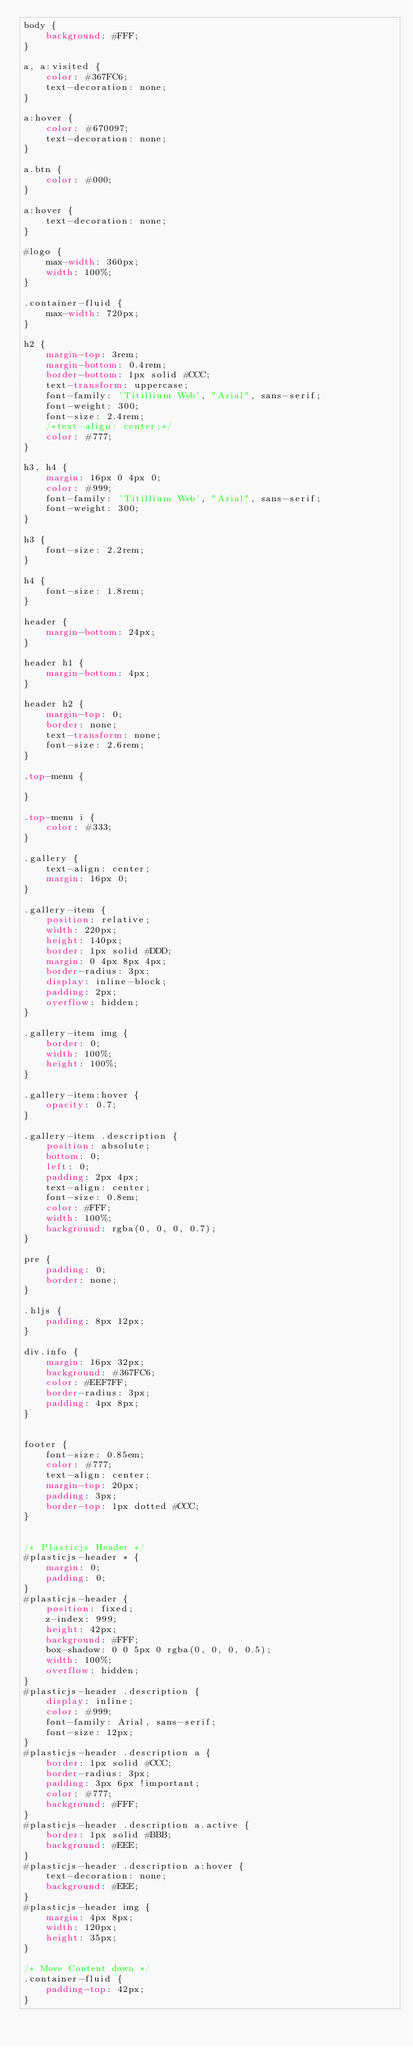<code> <loc_0><loc_0><loc_500><loc_500><_CSS_>body {
    background: #FFF;
}

a, a:visited {
    color: #367FC6;
    text-decoration: none;
}

a:hover {
    color: #670097;
    text-decoration: none;
}

a.btn {
    color: #000;
}

a:hover {
    text-decoration: none;
}

#logo {
    max-width: 360px;
    width: 100%;
}

.container-fluid {
    max-width: 720px;
}

h2 {
    margin-top: 3rem;
    margin-bottom: 0.4rem;
    border-bottom: 1px solid #CCC;
    text-transform: uppercase;
    font-family: 'Titillium Web', "Arial", sans-serif;
    font-weight: 300;
    font-size: 2.4rem;
    /*text-align: center;*/
    color: #777;
}

h3, h4 {
    margin: 16px 0 4px 0;
    color: #999;
    font-family: 'Titillium Web', "Arial", sans-serif;
    font-weight: 300;
}

h3 {
    font-size: 2.2rem;
}

h4 {
    font-size: 1.8rem;
}

header {
    margin-bottom: 24px;
}

header h1 {
    margin-bottom: 4px;
}

header h2 {
    margin-top: 0;
    border: none;
    text-transform: none;
    font-size: 2.6rem;
}

.top-menu {

}

.top-menu i {
    color: #333;
}

.gallery {
    text-align: center;
    margin: 16px 0;
}

.gallery-item {
    position: relative;
    width: 220px;
    height: 140px;
    border: 1px solid #DDD;
    margin: 0 4px 8px 4px;
    border-radius: 3px;
    display: inline-block;
    padding: 2px;
    overflow: hidden;
}

.gallery-item img {
    border: 0;
    width: 100%;
    height: 100%;
}

.gallery-item:hover {
    opacity: 0.7;
}

.gallery-item .description {
    position: absolute;
    bottom: 0;
    left: 0;
    padding: 2px 4px;
    text-align: center;
    font-size: 0.8em;
    color: #FFF;
    width: 100%;
    background: rgba(0, 0, 0, 0.7);
}

pre {
    padding: 0;
    border: none;
}

.hljs {
    padding: 8px 12px;
}

div.info {
    margin: 16px 32px;
    background: #367FC6;
    color: #EEF7FF;
    border-radius: 3px;
    padding: 4px 8px;
}


footer {
    font-size: 0.85em;
    color: #777;
    text-align: center;
    margin-top: 20px;
    padding: 3px;
    border-top: 1px dotted #CCC;
}


/* Plasticjs Header */
#plasticjs-header * {
    margin: 0;
    padding: 0;
}
#plasticjs-header {
    position: fixed;
    z-index: 999;
    height: 42px;
    background: #FFF;
    box-shadow: 0 0 5px 0 rgba(0, 0, 0, 0.5);
    width: 100%;
    overflow: hidden;
}
#plasticjs-header .description {
    display: inline;
    color: #999;
    font-family: Arial, sans-serif;
    font-size: 12px;
}
#plasticjs-header .description a {
    border: 1px solid #CCC;
    border-radius: 3px;
    padding: 3px 6px !important;
    color: #777;
    background: #FFF;
}
#plasticjs-header .description a.active {
    border: 1px solid #BBB;
    background: #EEE;
}
#plasticjs-header .description a:hover {
    text-decoration: none;
    background: #EEE;
}
#plasticjs-header img {
    margin: 4px 8px;
    width: 120px;
    height: 35px;
}

/* Move Content down */
.container-fluid {
    padding-top: 42px;
}
</code> 